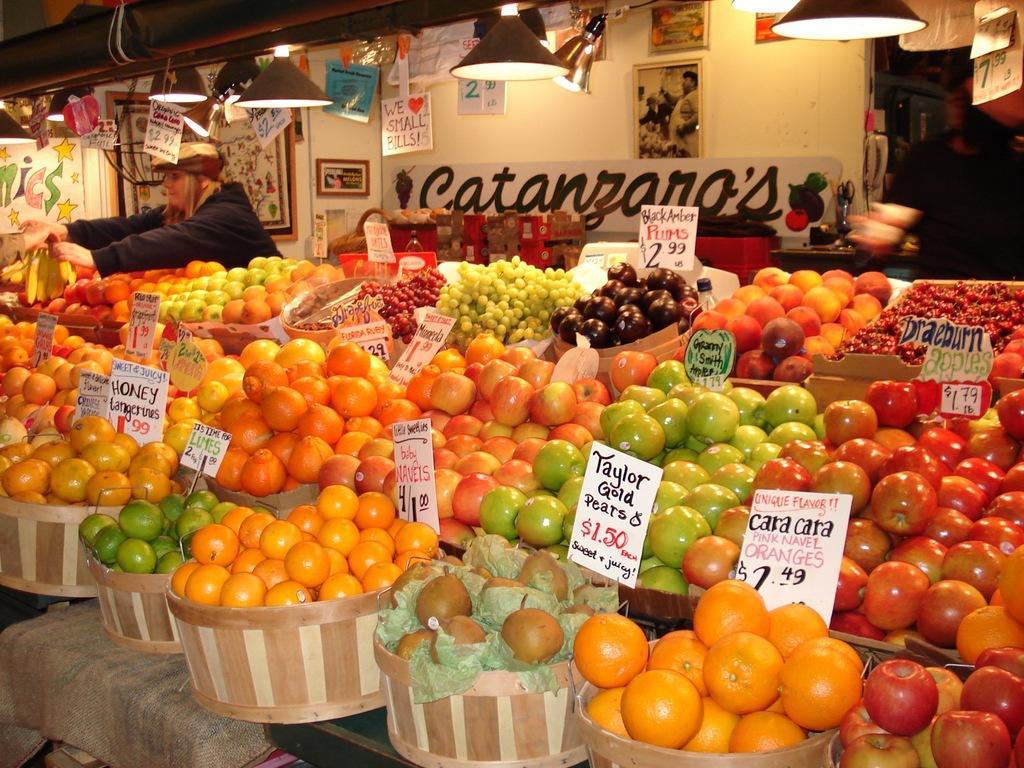In one or two sentences, can you explain what this image depicts? At the bottom of this image, there are fruits with the cards arranged in the wooden baskets, which are placed on a surface. In the background, there is a woman holding bananas, there are lights attached to the roof, there are photo frames and posters attached to the wall and there are other objects. 